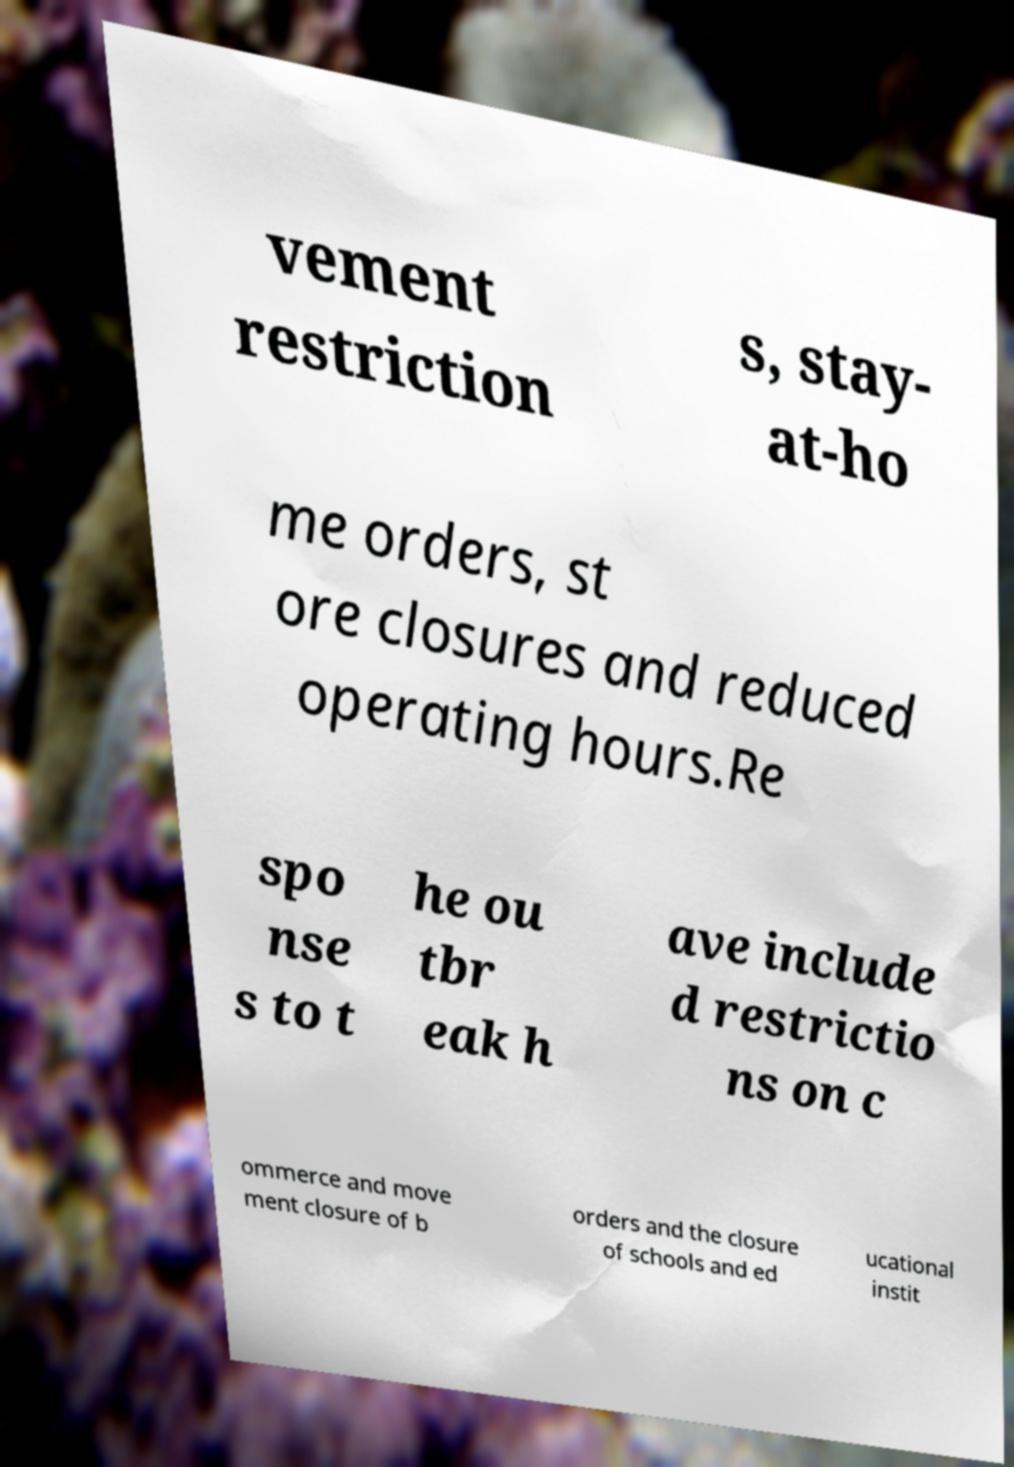Please read and relay the text visible in this image. What does it say? vement restriction s, stay- at-ho me orders, st ore closures and reduced operating hours.Re spo nse s to t he ou tbr eak h ave include d restrictio ns on c ommerce and move ment closure of b orders and the closure of schools and ed ucational instit 